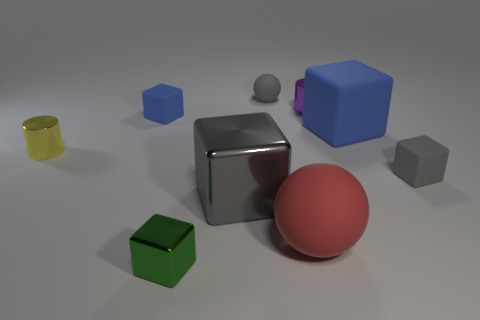Subtract all matte cubes. How many cubes are left? 2 Subtract all gray blocks. How many blocks are left? 3 Subtract 3 cubes. How many cubes are left? 2 Add 1 red objects. How many objects exist? 10 Subtract all cyan balls. How many green blocks are left? 1 Subtract all blocks. How many objects are left? 4 Add 8 small green things. How many small green things are left? 9 Add 8 tiny green cubes. How many tiny green cubes exist? 9 Subtract 0 red blocks. How many objects are left? 9 Subtract all cyan cylinders. Subtract all brown spheres. How many cylinders are left? 2 